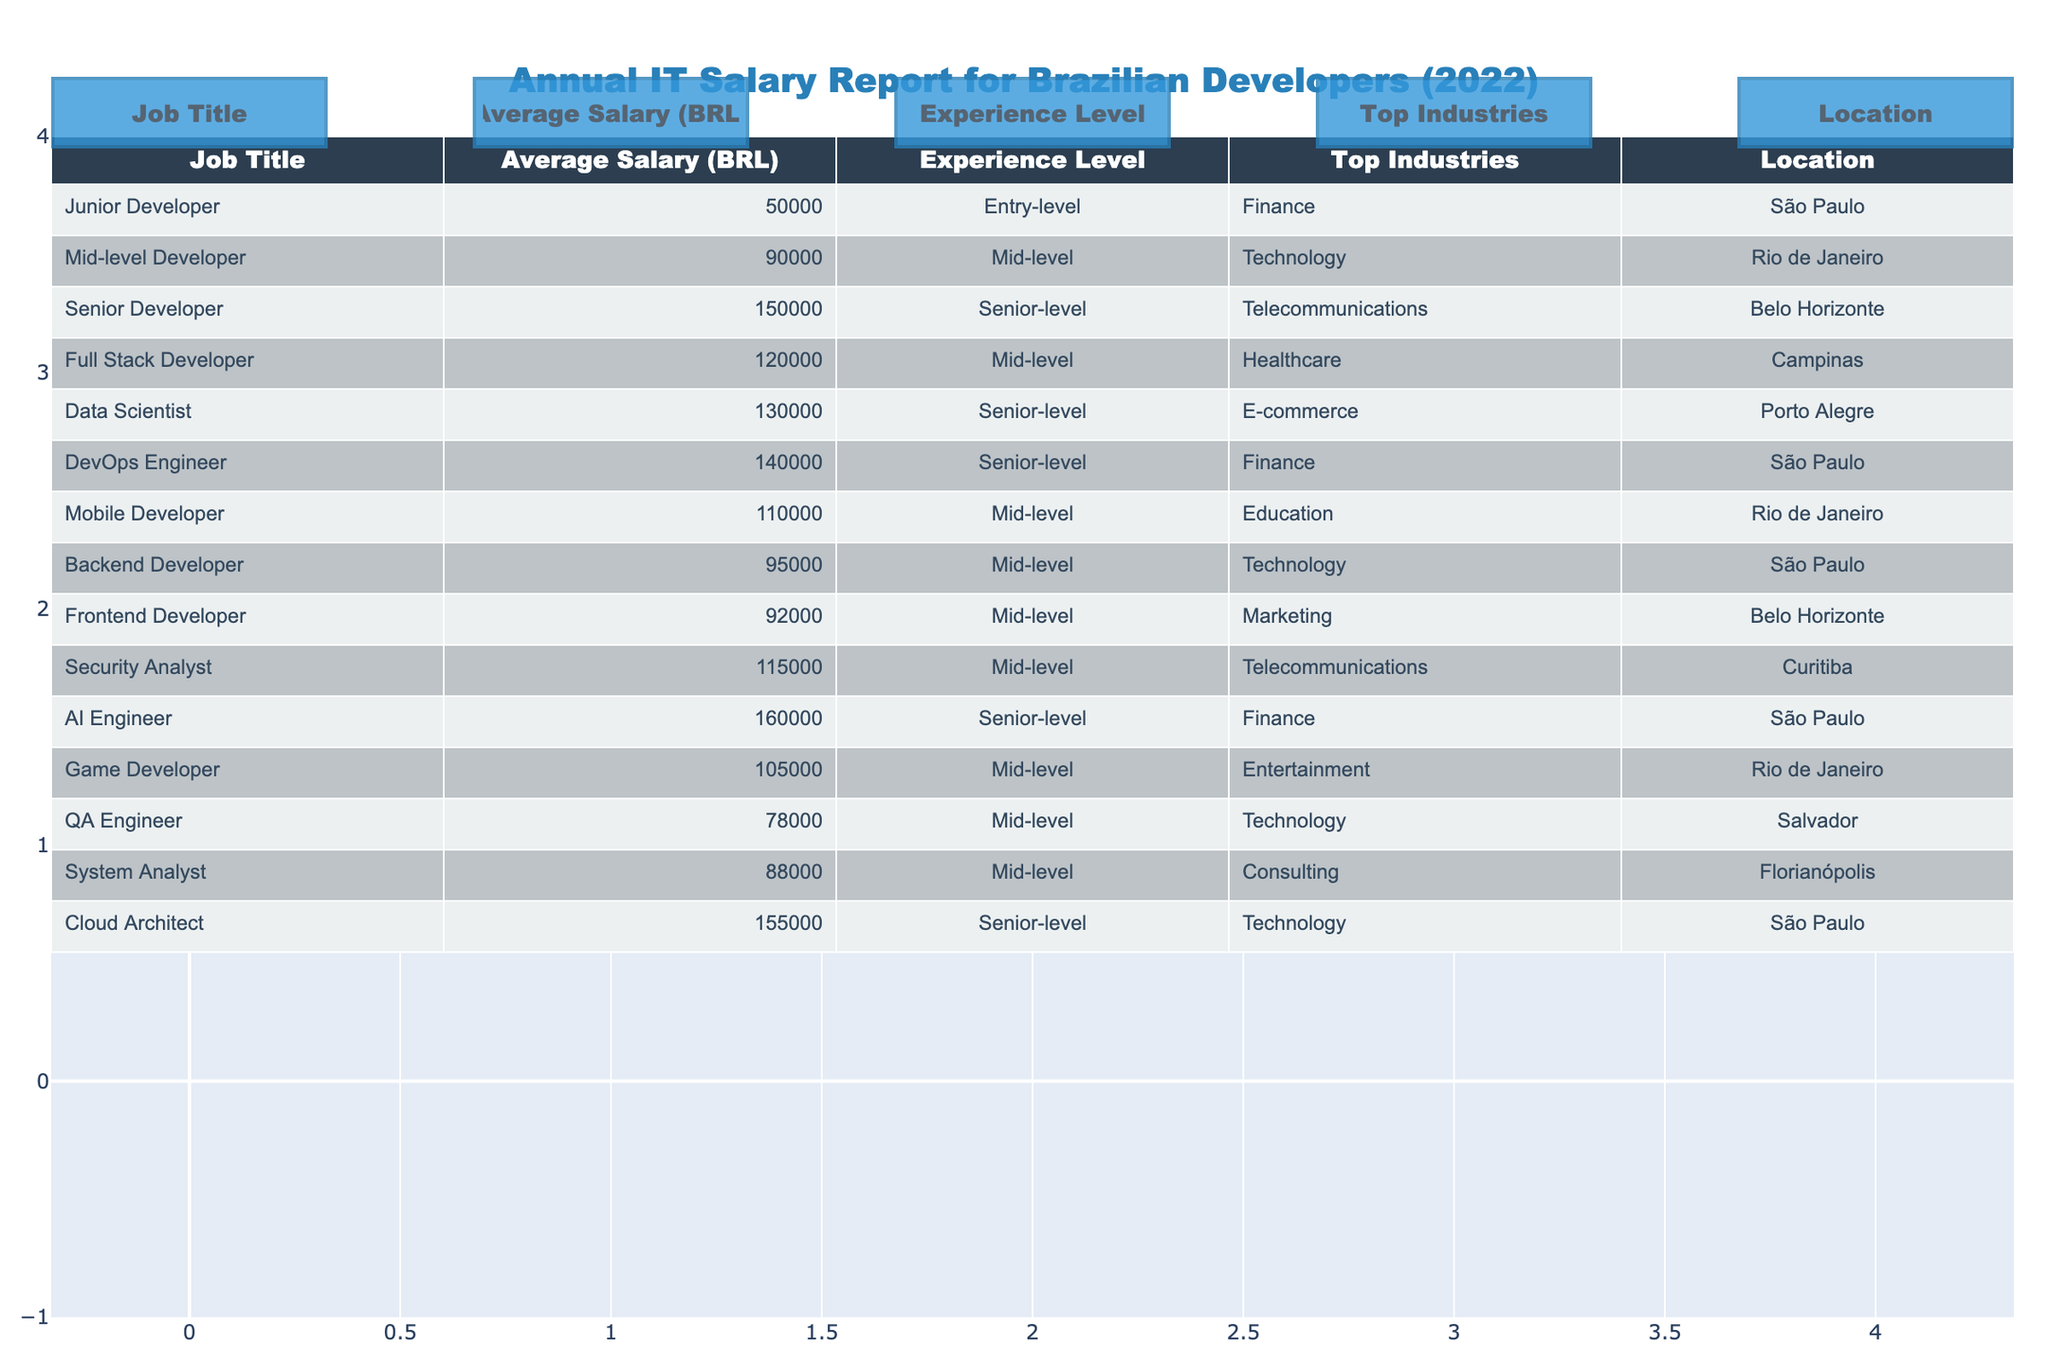What is the average salary of a Junior Developer in Brazil? The table shows that the average salary for a Junior Developer is 50,000 BRL.
Answer: 50,000 BRL Which job title has the highest average salary? By reviewing the table, the AI Engineer has the highest average salary of 160,000 BRL.
Answer: AI Engineer What is the total average salary of all the Mid-level Developers listed? The average salaries for Mid-level Developers are: 90,000 (Mid-level Developer) + 120,000 (Full Stack Developer) + 110,000 (Mobile Developer) + 95,000 (Backend Developer) + 92,000 (Frontend Developer) + 115,000 (Security Analyst) + 78,000 (QA Engineer) + 88,000 (System Analyst) + 105,000 (Game Developer) = 1,015,000 BRL. There are 9 Mid-level Developers, so the total average salary of Mid-level Developers is 1,015,000 / 9 ≈ 112,777.78 BRL, rounding gives 112,778 BRL.
Answer: 112,778 BRL Is the average salary for a Senior Developer higher than that of a Junior Developer? The average salary for a Senior Developer is 150,000 BRL, which is indeed higher than that of a Junior Developer, which is 50,000 BRL.
Answer: Yes What is the difference in average salary between a Data Scientist and a DevOps Engineer? The average salary for a Data Scientist is 130,000 BRL, and for a DevOps Engineer, it's 140,000 BRL. The difference is 140,000 - 130,000 = 10,000 BRL.
Answer: 10,000 BRL Which location has the highest average salary for developers according to the table? By checking the salaries listed per location, São Paulo has three developers with salaries of 50,000 (Junior Developer), 140,000 (DevOps Engineer), and 160,000 (AI Engineer), for a total of 350,000 BRL, and averaging this with 3 gives approximately 116,666.67 BRL. Other locations have lower overall averages. Hence, São Paulo has the highest average salary.
Answer: São Paulo What is the average salary for Telecommunications-related positions? The Telecommunications-related positions are Senior Developer (150,000 BRL), Security Analyst (115,000 BRL), and the average is (150,000 + 115,000) / 2 = 132,500 BRL.
Answer: 132,500 BRL Are there more Mid-level Developers or Senior-level Developers represented in the table? The table lists 9 Mid-level Developers and 6 Senior-level Developers. Thus, there are more Mid-level Developers.
Answer: More Mid-level Developers What is the average salary of all the positions in the listed locations? The sum of average salaries for all positions is: 50,000 + 90,000 + 150,000 + 120,000 + 130,000 + 140,000 + 110,000 + 95,000 + 92,000 + 115,000 + 160,000 + 105,000 + 78,000 + 88,000 + 155,000 = 1,610,000 BRL. There are 15 positions, so the average salary is 1,610,000 / 15 = 107,333.33 BRL, rounding gives 107,333 BRL.
Answer: 107,333 BRL Which job title has the lowest average salary? According to the table, the Junior Developer has the lowest average salary of 50,000 BRL.
Answer: Junior Developer 